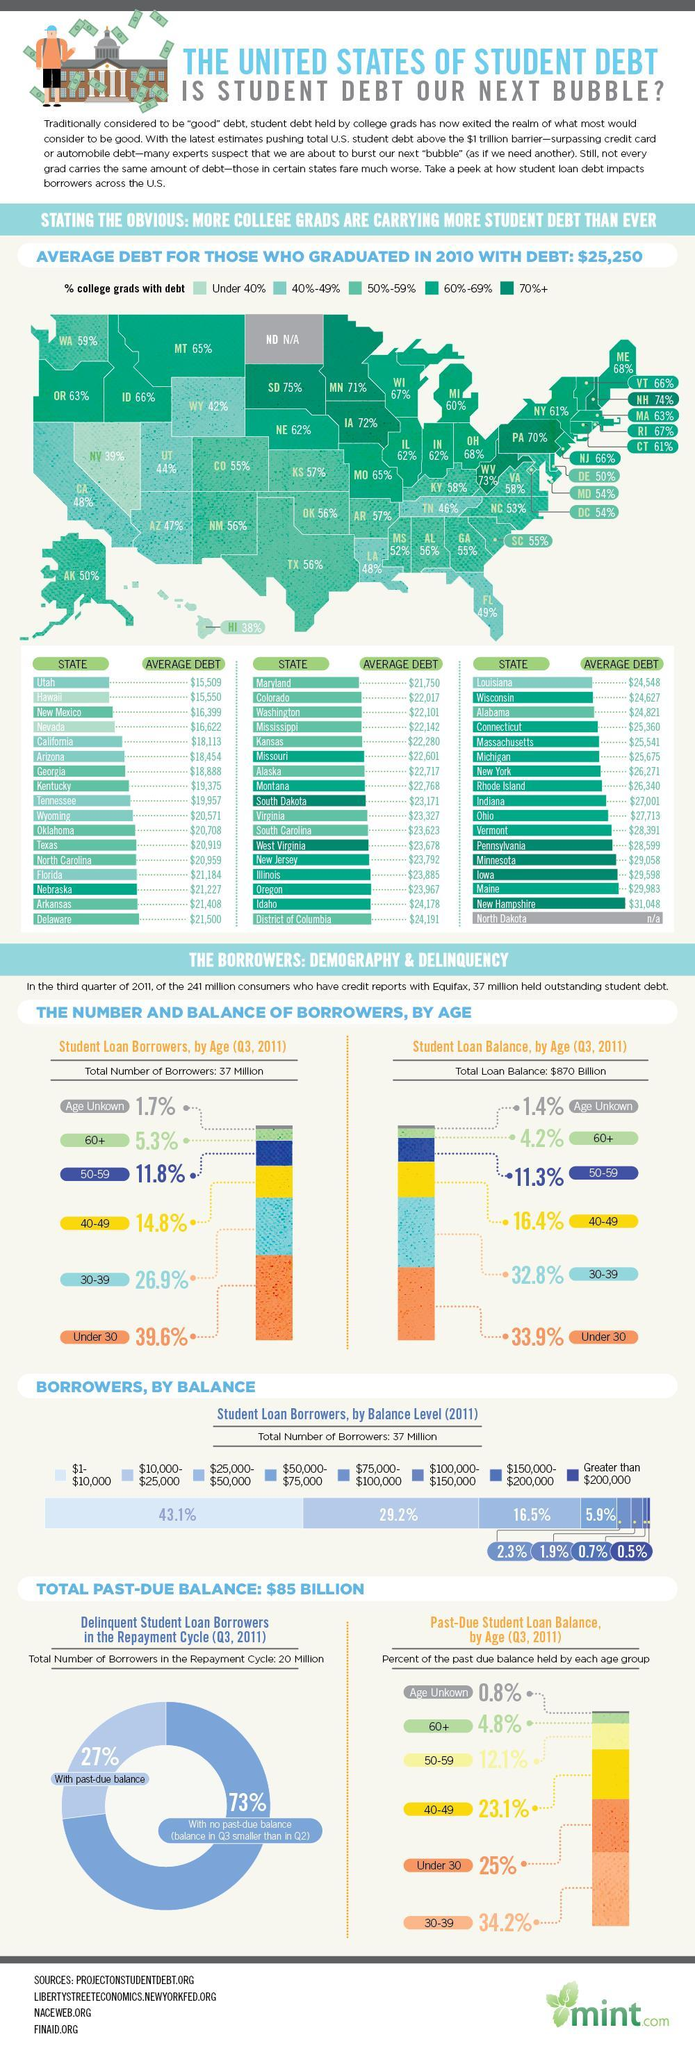What is the total Student loan balance  in the U.S. in 2011?
Answer the question with a short phrase. $870 Billion Which state in U.S. has the least average debt for those who graduated in 2010? Utah What percent of student loan borrowers are between the age of 30-39 in U.S.? 26.9% What is the percent of the past due student loan balance held by age group of 60+ in 2011? 4.8% What percent of student loan borrowers are under the age of 30 in U.S.? 39.6% Which state in U.S. has the highest average debt for those who graduated in 2010? New Hampshire Which age group has the highest percent of the past due student loan balance in 2011? 30-39 What is the percent of the past due student loan balance held by age group under 30 in 2011? 25% 